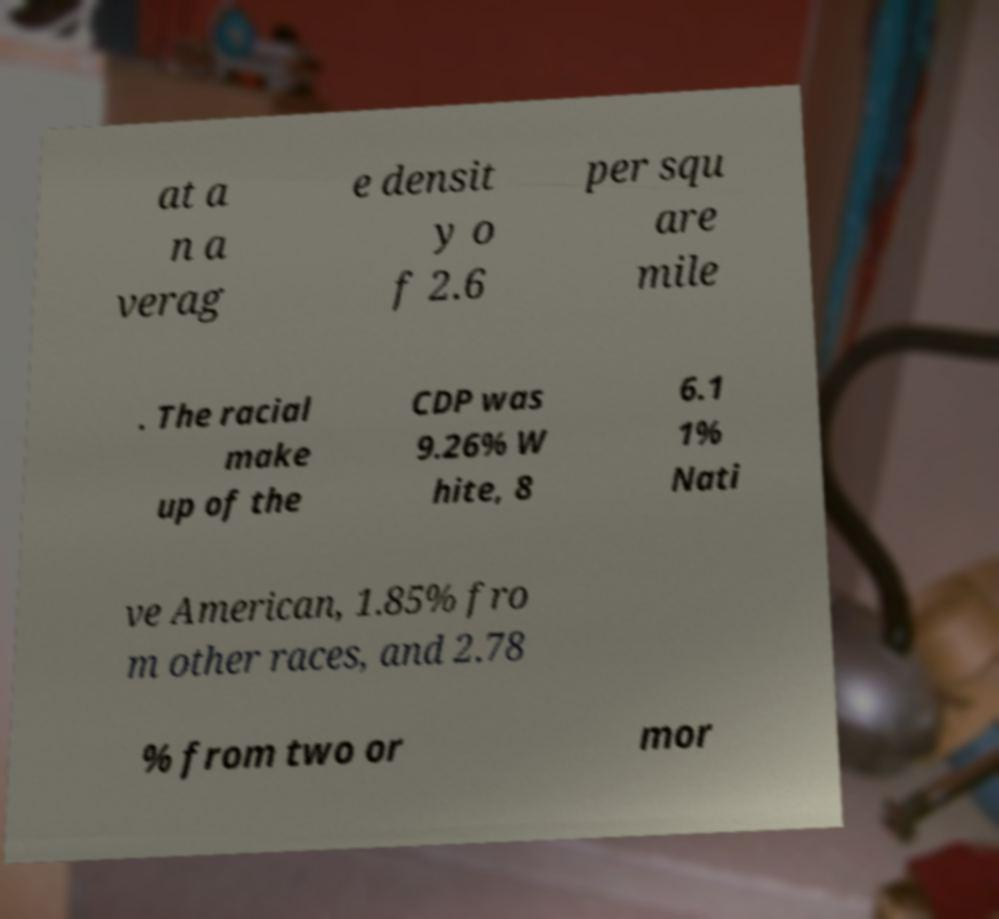Could you extract and type out the text from this image? at a n a verag e densit y o f 2.6 per squ are mile . The racial make up of the CDP was 9.26% W hite, 8 6.1 1% Nati ve American, 1.85% fro m other races, and 2.78 % from two or mor 